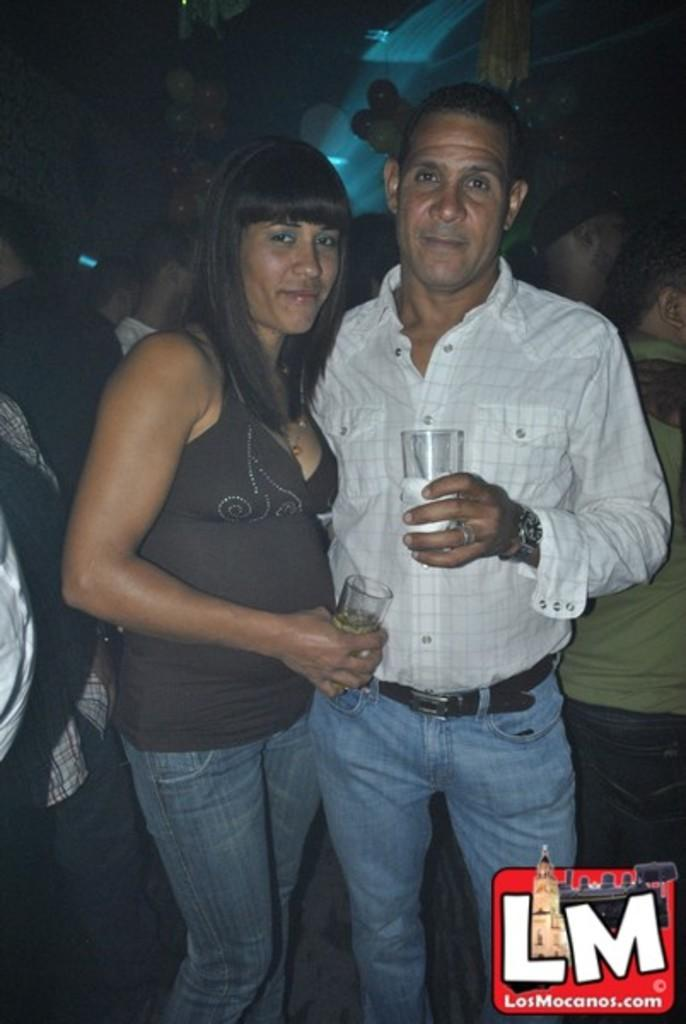Who are the two people in the image? There is a man and a woman in the image. What are the man and woman holding in their hands? The man and woman are holding glasses. Can you describe the setting of the image? There are many people in the background of the image. Is there any additional information about the image itself? There is a watermark in the right corner of the image. What type of polish is the woman applying to her nails in the image? There is no indication in the image that the woman is applying polish to her nails, as she is holding a glass instead. 